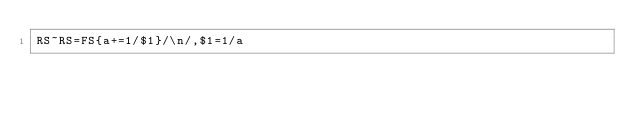<code> <loc_0><loc_0><loc_500><loc_500><_Awk_>RS~RS=FS{a+=1/$1}/\n/,$1=1/a</code> 